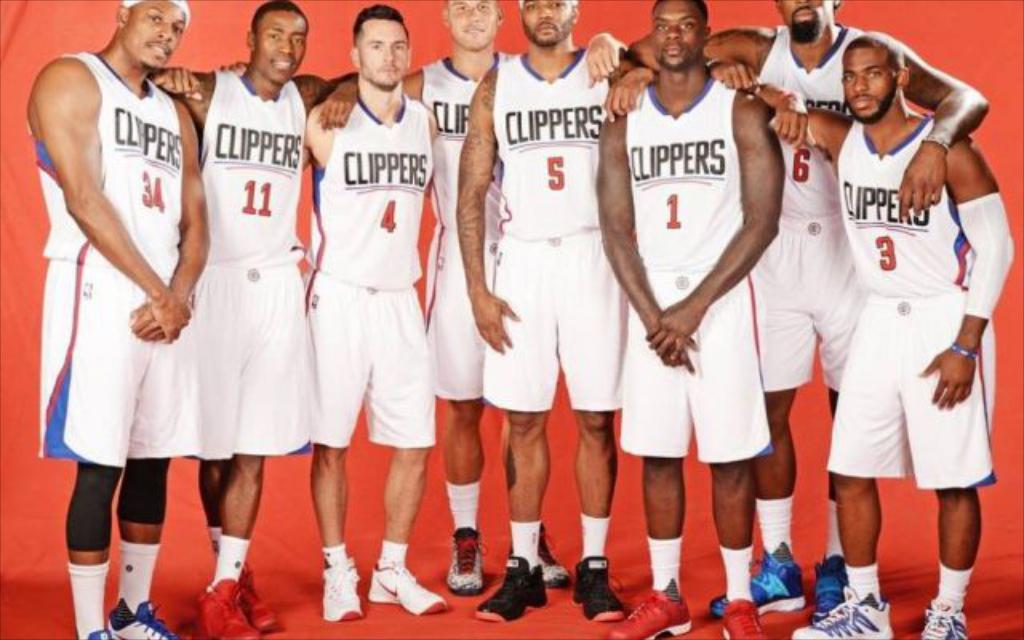Provide a one-sentence caption for the provided image. An image of the Clippers basketball team posing for a picture. 